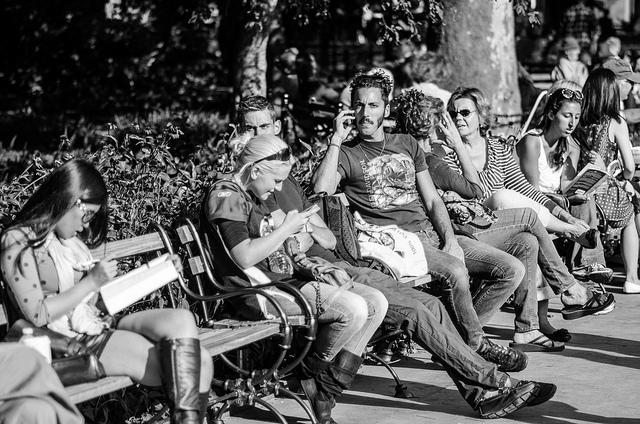What are they all doing? Please explain your reasoning. relaxing. They are resting. 